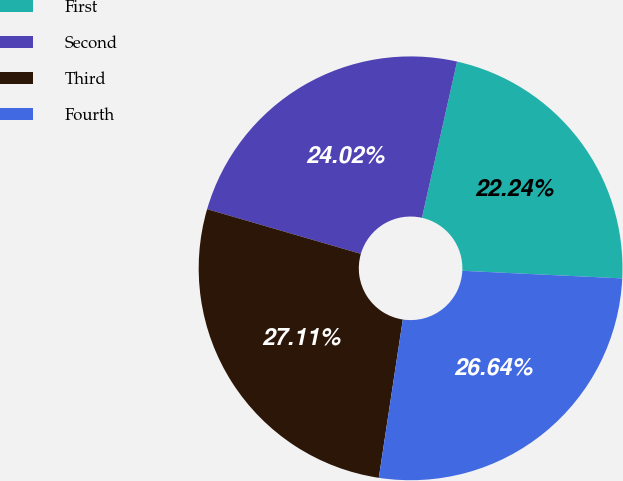Convert chart to OTSL. <chart><loc_0><loc_0><loc_500><loc_500><pie_chart><fcel>First<fcel>Second<fcel>Third<fcel>Fourth<nl><fcel>22.24%<fcel>24.02%<fcel>27.11%<fcel>26.64%<nl></chart> 